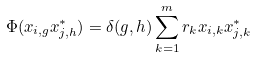Convert formula to latex. <formula><loc_0><loc_0><loc_500><loc_500>\Phi ( x _ { i , g } x _ { j , h } ^ { \ast } ) = \delta ( g , h ) \sum _ { k = 1 } ^ { m } r _ { k } x _ { i , k } x _ { j , k } ^ { \ast }</formula> 